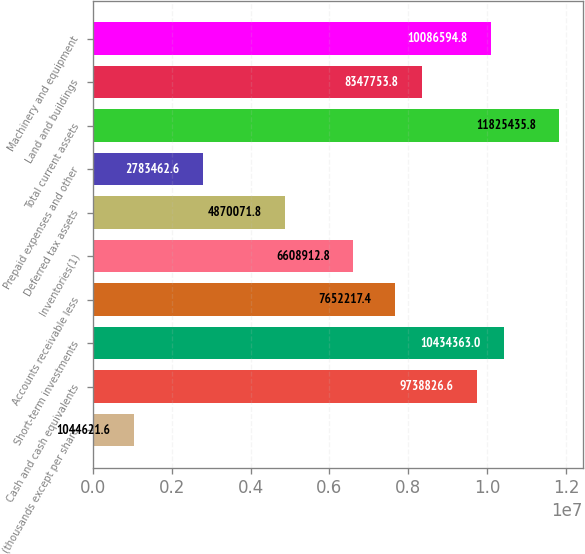<chart> <loc_0><loc_0><loc_500><loc_500><bar_chart><fcel>(thousands except per share<fcel>Cash and cash equivalents<fcel>Short-term investments<fcel>Accounts receivable less<fcel>Inventories(1)<fcel>Deferred tax assets<fcel>Prepaid expenses and other<fcel>Total current assets<fcel>Land and buildings<fcel>Machinery and equipment<nl><fcel>1.04462e+06<fcel>9.73883e+06<fcel>1.04344e+07<fcel>7.65222e+06<fcel>6.60891e+06<fcel>4.87007e+06<fcel>2.78346e+06<fcel>1.18254e+07<fcel>8.34775e+06<fcel>1.00866e+07<nl></chart> 